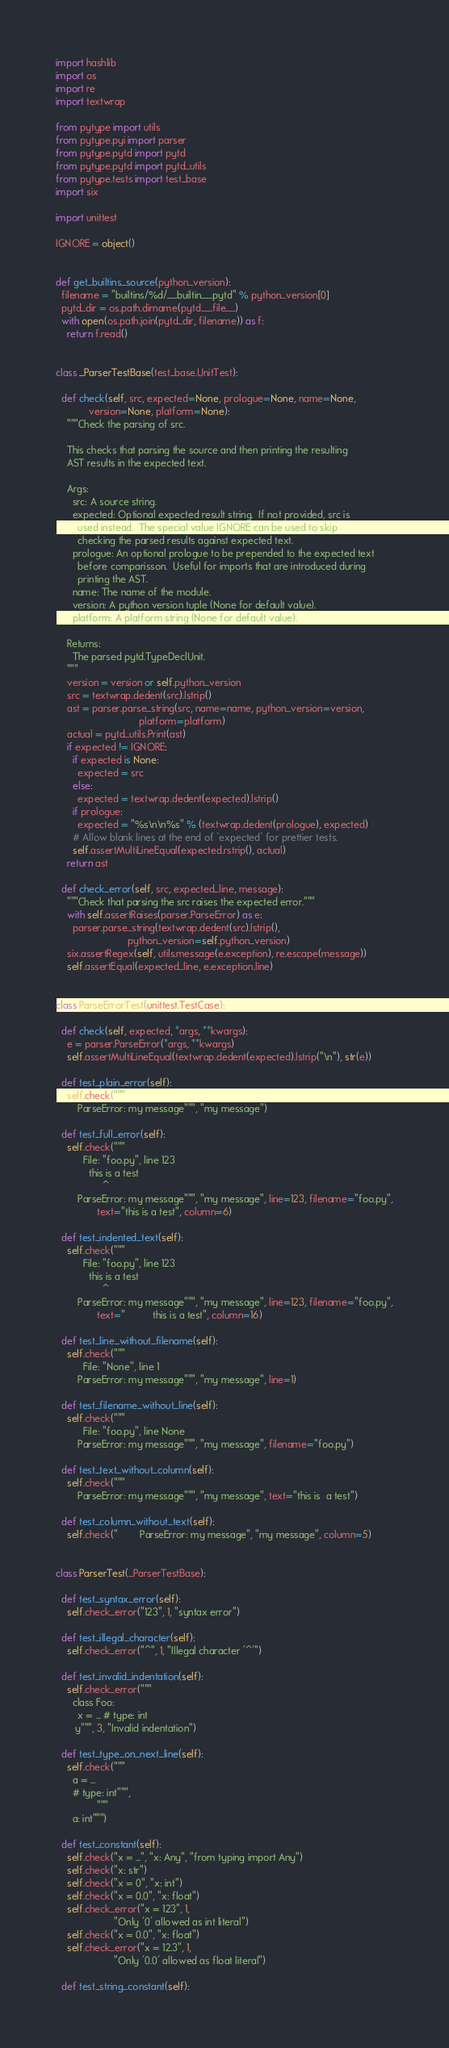Convert code to text. <code><loc_0><loc_0><loc_500><loc_500><_Python_>import hashlib
import os
import re
import textwrap

from pytype import utils
from pytype.pyi import parser
from pytype.pytd import pytd
from pytype.pytd import pytd_utils
from pytype.tests import test_base
import six

import unittest

IGNORE = object()


def get_builtins_source(python_version):
  filename = "builtins/%d/__builtin__.pytd" % python_version[0]
  pytd_dir = os.path.dirname(pytd.__file__)
  with open(os.path.join(pytd_dir, filename)) as f:
    return f.read()


class _ParserTestBase(test_base.UnitTest):

  def check(self, src, expected=None, prologue=None, name=None,
            version=None, platform=None):
    """Check the parsing of src.

    This checks that parsing the source and then printing the resulting
    AST results in the expected text.

    Args:
      src: A source string.
      expected: Optional expected result string.  If not provided, src is
        used instead.  The special value IGNORE can be used to skip
        checking the parsed results against expected text.
      prologue: An optional prologue to be prepended to the expected text
        before comparisson.  Useful for imports that are introduced during
        printing the AST.
      name: The name of the module.
      version: A python version tuple (None for default value).
      platform: A platform string (None for default value).

    Returns:
      The parsed pytd.TypeDeclUnit.
    """
    version = version or self.python_version
    src = textwrap.dedent(src).lstrip()
    ast = parser.parse_string(src, name=name, python_version=version,
                              platform=platform)
    actual = pytd_utils.Print(ast)
    if expected != IGNORE:
      if expected is None:
        expected = src
      else:
        expected = textwrap.dedent(expected).lstrip()
      if prologue:
        expected = "%s\n\n%s" % (textwrap.dedent(prologue), expected)
      # Allow blank lines at the end of `expected` for prettier tests.
      self.assertMultiLineEqual(expected.rstrip(), actual)
    return ast

  def check_error(self, src, expected_line, message):
    """Check that parsing the src raises the expected error."""
    with self.assertRaises(parser.ParseError) as e:
      parser.parse_string(textwrap.dedent(src).lstrip(),
                          python_version=self.python_version)
    six.assertRegex(self, utils.message(e.exception), re.escape(message))
    self.assertEqual(expected_line, e.exception.line)


class ParseErrorTest(unittest.TestCase):

  def check(self, expected, *args, **kwargs):
    e = parser.ParseError(*args, **kwargs)
    self.assertMultiLineEqual(textwrap.dedent(expected).lstrip("\n"), str(e))

  def test_plain_error(self):
    self.check("""
        ParseError: my message""", "my message")

  def test_full_error(self):
    self.check("""
          File: "foo.py", line 123
            this is a test
                 ^
        ParseError: my message""", "my message", line=123, filename="foo.py",
               text="this is a test", column=6)

  def test_indented_text(self):
    self.check("""
          File: "foo.py", line 123
            this is a test
                 ^
        ParseError: my message""", "my message", line=123, filename="foo.py",
               text="          this is a test", column=16)

  def test_line_without_filename(self):
    self.check("""
          File: "None", line 1
        ParseError: my message""", "my message", line=1)

  def test_filename_without_line(self):
    self.check("""
          File: "foo.py", line None
        ParseError: my message""", "my message", filename="foo.py")

  def test_text_without_column(self):
    self.check("""
        ParseError: my message""", "my message", text="this is  a test")

  def test_column_without_text(self):
    self.check("        ParseError: my message", "my message", column=5)


class ParserTest(_ParserTestBase):

  def test_syntax_error(self):
    self.check_error("123", 1, "syntax error")

  def test_illegal_character(self):
    self.check_error("^", 1, "Illegal character '^'")

  def test_invalid_indentation(self):
    self.check_error("""
      class Foo:
        x = ... # type: int
       y""", 3, "Invalid indentation")

  def test_type_on_next_line(self):
    self.check("""
      a = ...
      # type: int""",
               """
      a: int""")

  def test_constant(self):
    self.check("x = ...", "x: Any", "from typing import Any")
    self.check("x: str")
    self.check("x = 0", "x: int")
    self.check("x = 0.0", "x: float")
    self.check_error("x = 123", 1,
                     "Only '0' allowed as int literal")
    self.check("x = 0.0", "x: float")
    self.check_error("x = 12.3", 1,
                     "Only '0.0' allowed as float literal")

  def test_string_constant(self):</code> 